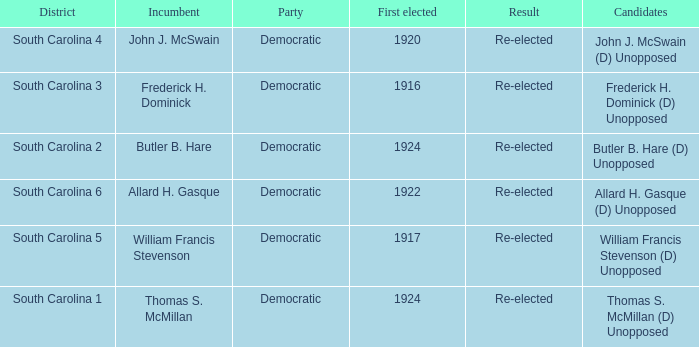What is the result for south carolina 4? Re-elected. 